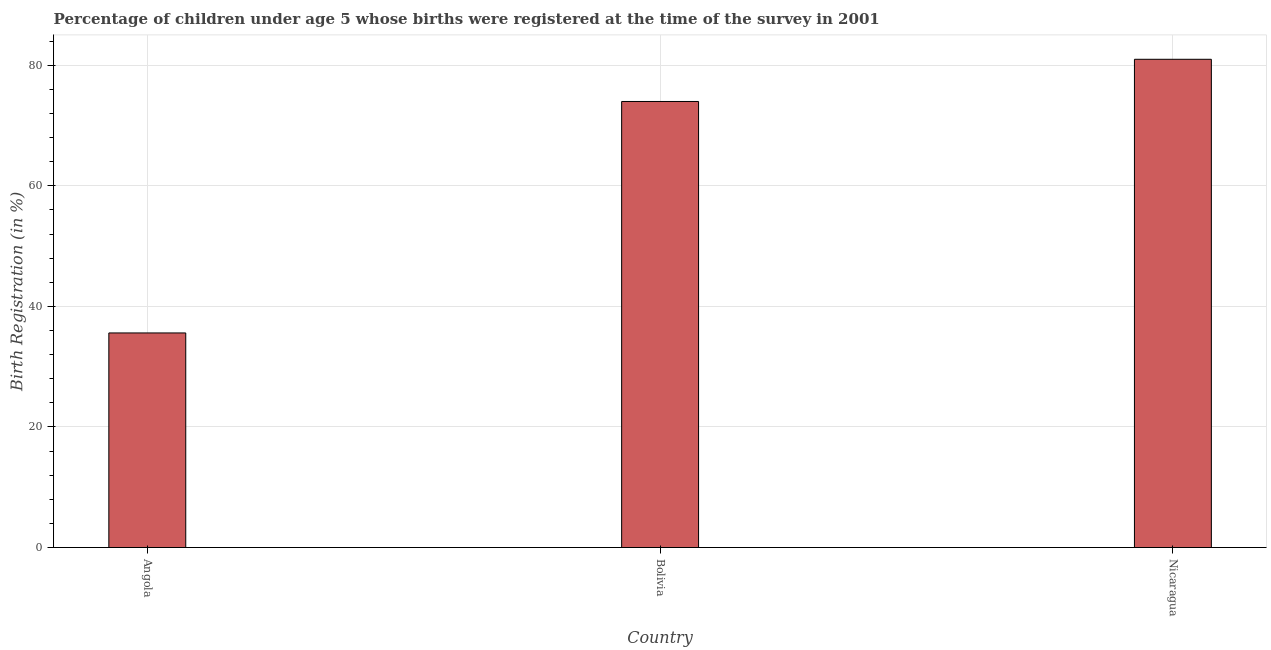Does the graph contain any zero values?
Keep it short and to the point. No. Does the graph contain grids?
Offer a terse response. Yes. What is the title of the graph?
Your answer should be compact. Percentage of children under age 5 whose births were registered at the time of the survey in 2001. What is the label or title of the Y-axis?
Your answer should be very brief. Birth Registration (in %). Across all countries, what is the maximum birth registration?
Your answer should be very brief. 81. Across all countries, what is the minimum birth registration?
Your response must be concise. 35.6. In which country was the birth registration maximum?
Ensure brevity in your answer.  Nicaragua. In which country was the birth registration minimum?
Offer a terse response. Angola. What is the sum of the birth registration?
Provide a succinct answer. 190.6. What is the difference between the birth registration in Bolivia and Nicaragua?
Your response must be concise. -7. What is the average birth registration per country?
Offer a terse response. 63.53. What is the median birth registration?
Your answer should be compact. 74. What is the ratio of the birth registration in Angola to that in Bolivia?
Ensure brevity in your answer.  0.48. Is the difference between the birth registration in Bolivia and Nicaragua greater than the difference between any two countries?
Offer a very short reply. No. What is the difference between the highest and the second highest birth registration?
Ensure brevity in your answer.  7. Is the sum of the birth registration in Angola and Nicaragua greater than the maximum birth registration across all countries?
Your answer should be compact. Yes. What is the difference between the highest and the lowest birth registration?
Your response must be concise. 45.4. In how many countries, is the birth registration greater than the average birth registration taken over all countries?
Keep it short and to the point. 2. How many countries are there in the graph?
Your answer should be compact. 3. What is the difference between two consecutive major ticks on the Y-axis?
Provide a succinct answer. 20. Are the values on the major ticks of Y-axis written in scientific E-notation?
Keep it short and to the point. No. What is the Birth Registration (in %) of Angola?
Provide a succinct answer. 35.6. What is the Birth Registration (in %) in Bolivia?
Provide a succinct answer. 74. What is the difference between the Birth Registration (in %) in Angola and Bolivia?
Offer a terse response. -38.4. What is the difference between the Birth Registration (in %) in Angola and Nicaragua?
Offer a terse response. -45.4. What is the ratio of the Birth Registration (in %) in Angola to that in Bolivia?
Provide a short and direct response. 0.48. What is the ratio of the Birth Registration (in %) in Angola to that in Nicaragua?
Offer a terse response. 0.44. What is the ratio of the Birth Registration (in %) in Bolivia to that in Nicaragua?
Your answer should be very brief. 0.91. 